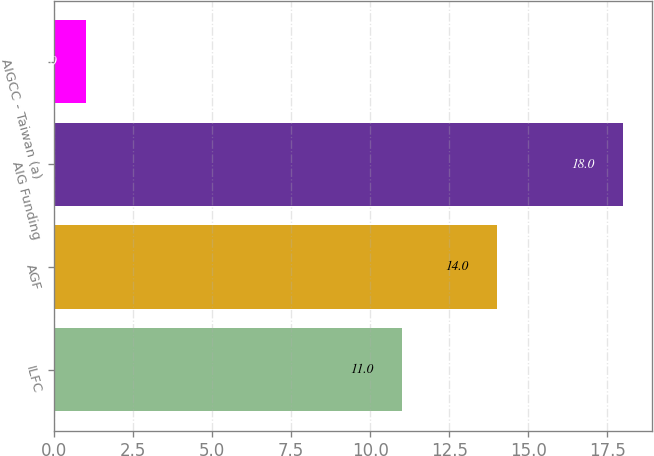Convert chart to OTSL. <chart><loc_0><loc_0><loc_500><loc_500><bar_chart><fcel>ILFC<fcel>AGF<fcel>AIG Funding<fcel>AIGCC - Taiwan (a)<nl><fcel>11<fcel>14<fcel>18<fcel>1<nl></chart> 